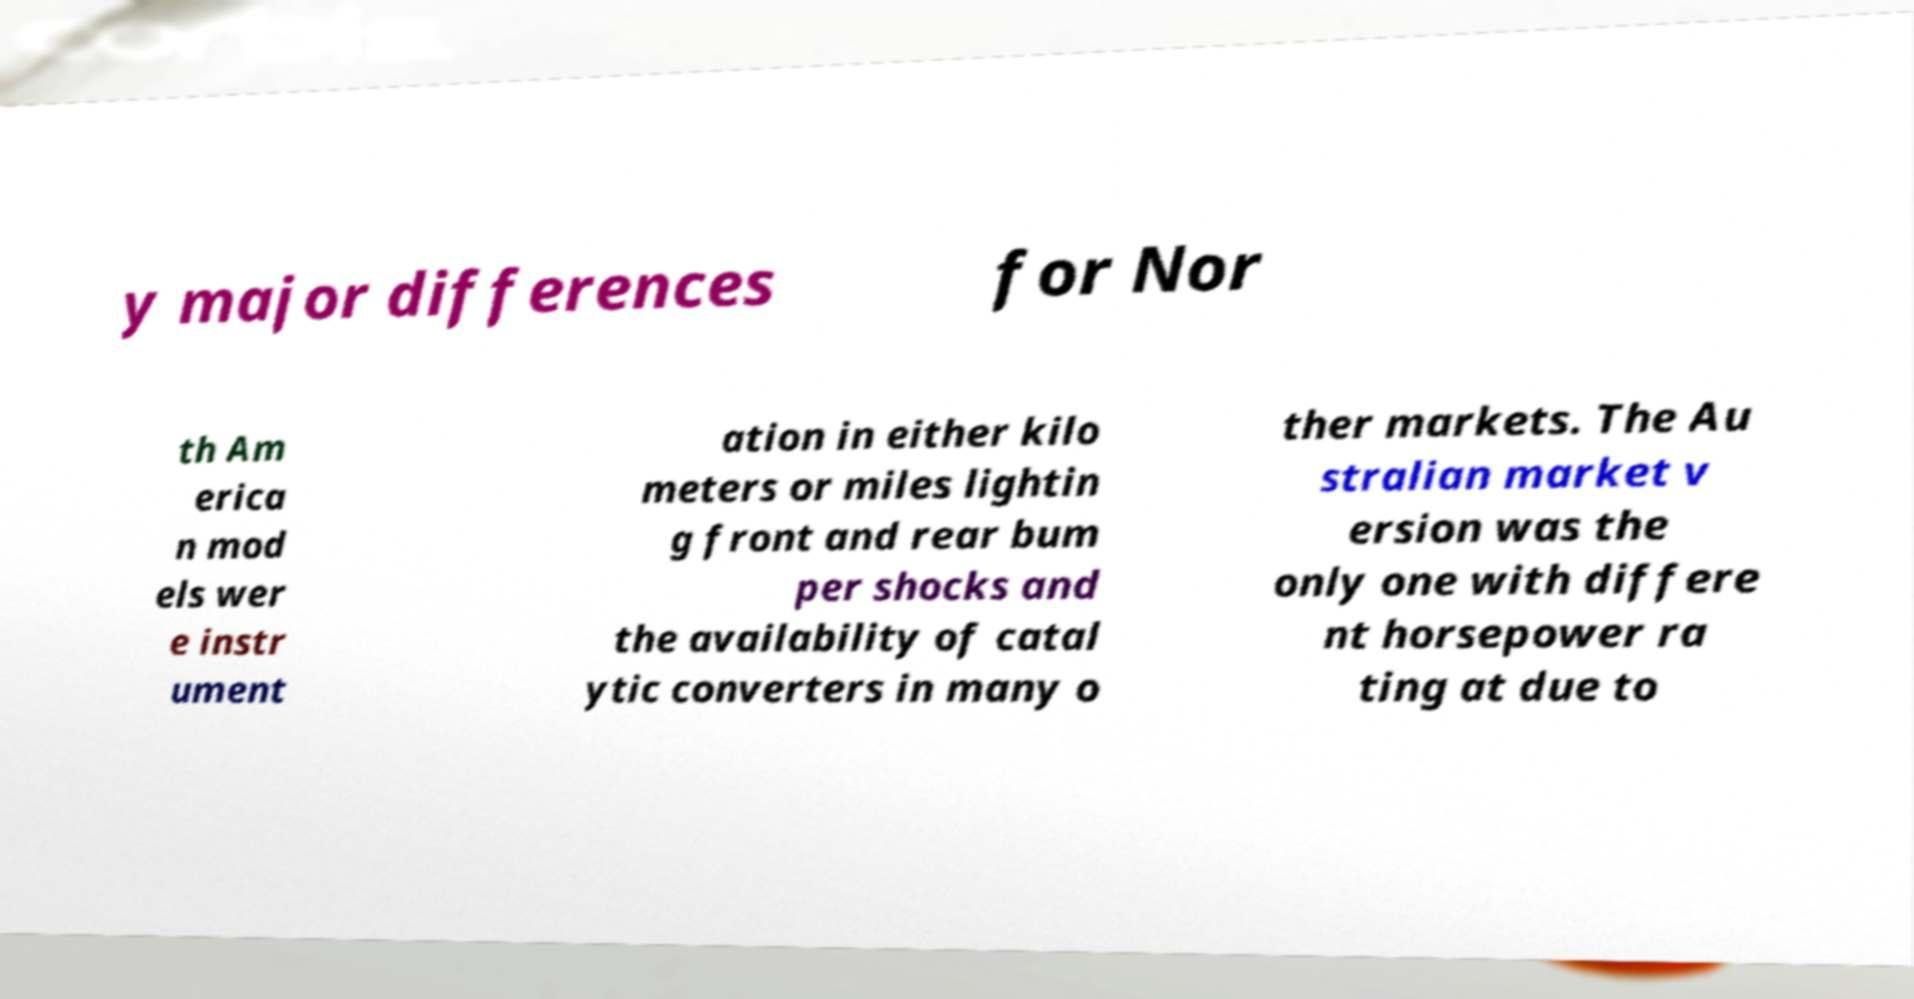Can you read and provide the text displayed in the image?This photo seems to have some interesting text. Can you extract and type it out for me? y major differences for Nor th Am erica n mod els wer e instr ument ation in either kilo meters or miles lightin g front and rear bum per shocks and the availability of catal ytic converters in many o ther markets. The Au stralian market v ersion was the only one with differe nt horsepower ra ting at due to 